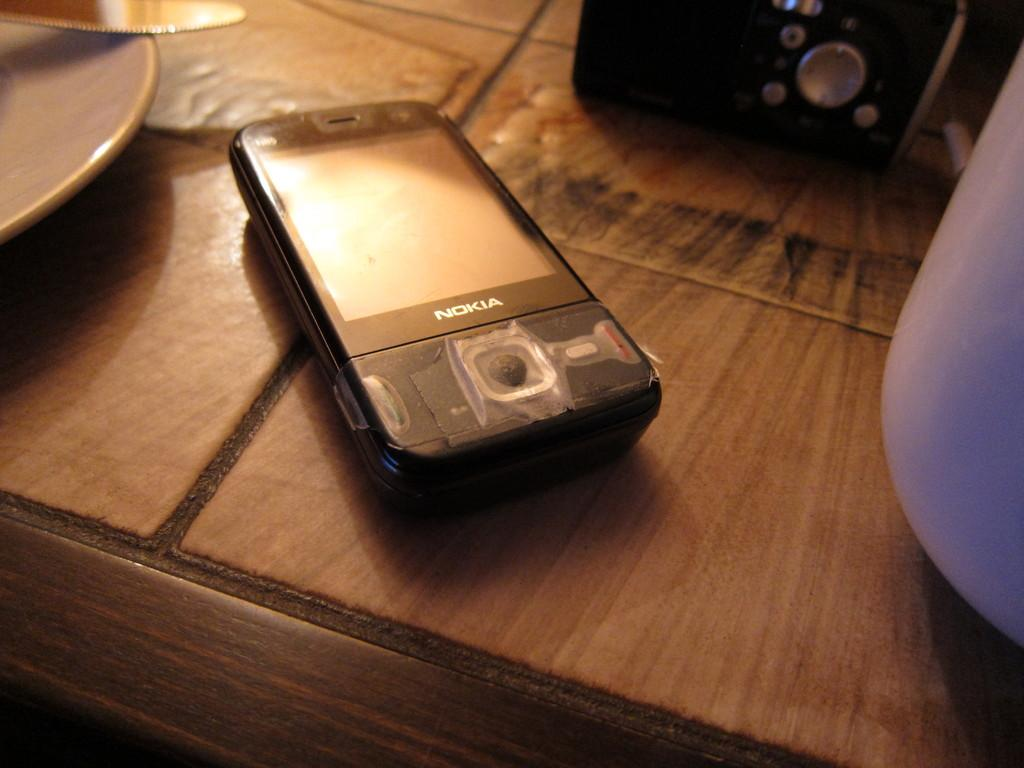Provide a one-sentence caption for the provided image. A Nokia phone with the plastic protection covering still on it sits on a table. 